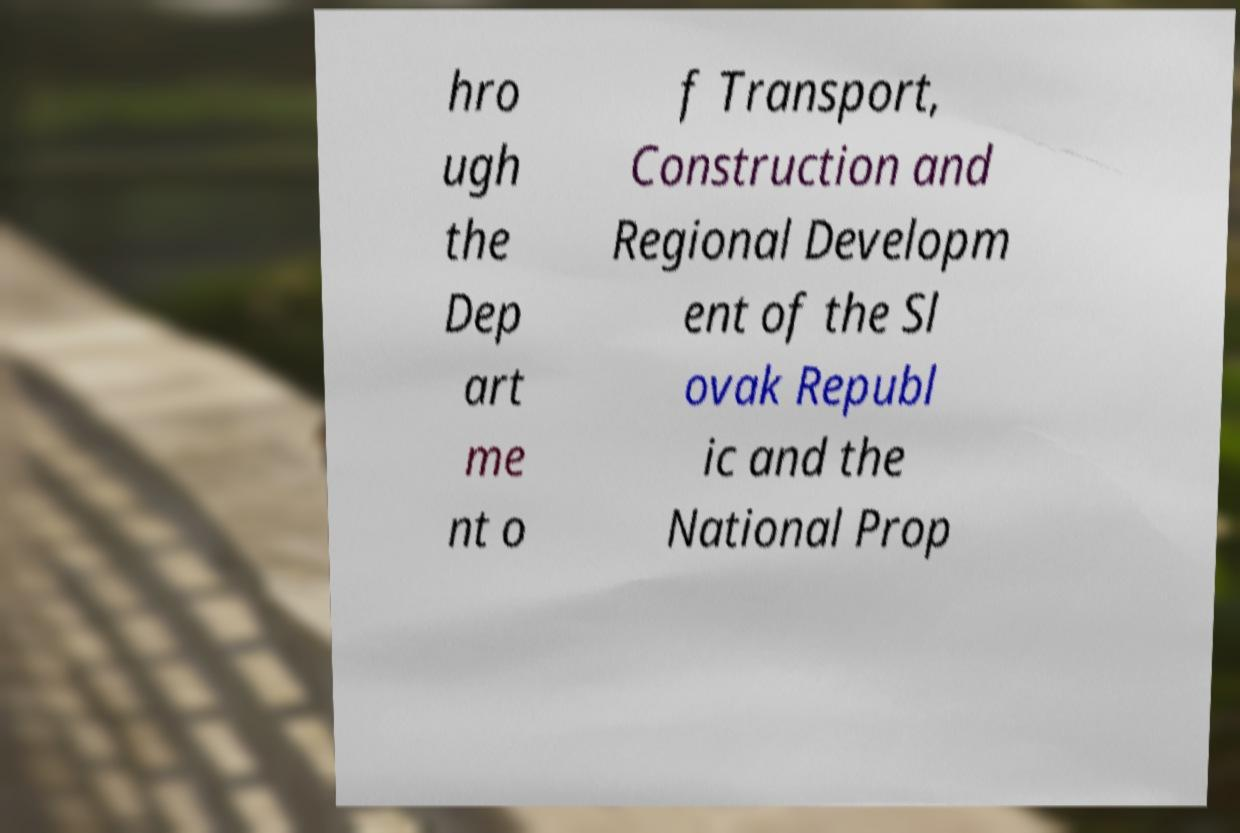What messages or text are displayed in this image? I need them in a readable, typed format. hro ugh the Dep art me nt o f Transport, Construction and Regional Developm ent of the Sl ovak Republ ic and the National Prop 